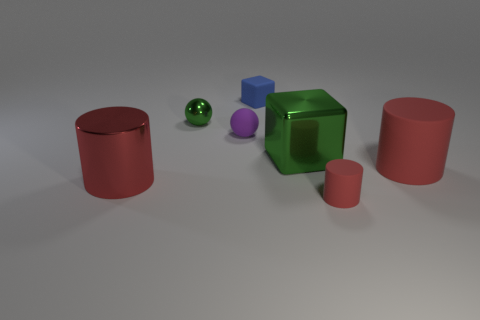Are any small rubber objects visible?
Your answer should be very brief. Yes. There is another shiny thing that is the same size as the blue object; what color is it?
Offer a very short reply. Green. How many tiny green metal objects are the same shape as the large green metallic object?
Your answer should be very brief. 0. Does the tiny thing in front of the big red shiny cylinder have the same material as the tiny purple ball?
Offer a terse response. Yes. What number of cylinders are purple matte objects or large red matte objects?
Give a very brief answer. 1. What shape is the big red object that is on the right side of the cylinder in front of the big cylinder that is left of the rubber ball?
Provide a short and direct response. Cylinder. There is a thing that is the same color as the large cube; what shape is it?
Your answer should be very brief. Sphere. What number of purple metal objects are the same size as the green ball?
Your response must be concise. 0. Are there any red things in front of the red matte thing behind the tiny red matte object?
Give a very brief answer. Yes. What number of things are either big red shiny cylinders or green objects?
Offer a terse response. 3. 